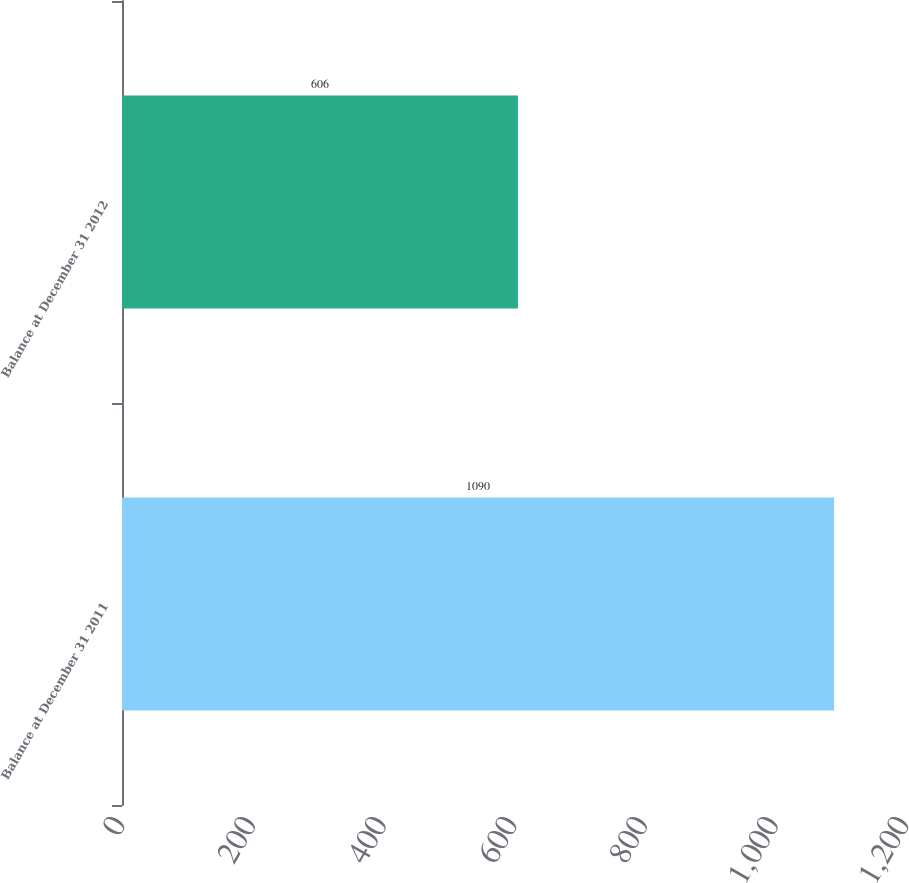Convert chart. <chart><loc_0><loc_0><loc_500><loc_500><bar_chart><fcel>Balance at December 31 2011<fcel>Balance at December 31 2012<nl><fcel>1090<fcel>606<nl></chart> 